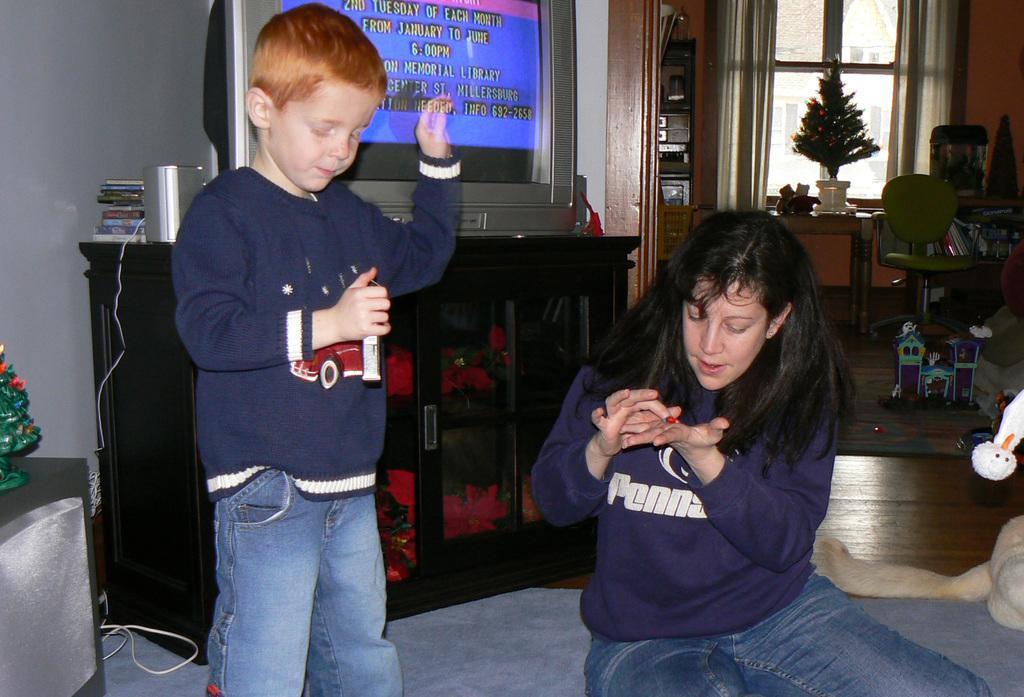Please provide a concise description of this image. There is a woman sitting and this boy standing and holding an object. Left side of the image we can see Christmas tree on the table. Behind these two people we can see television,books and object above the cupboards. In the background we can see chairs,toys,Christmas tree on the table,window and curtains. 